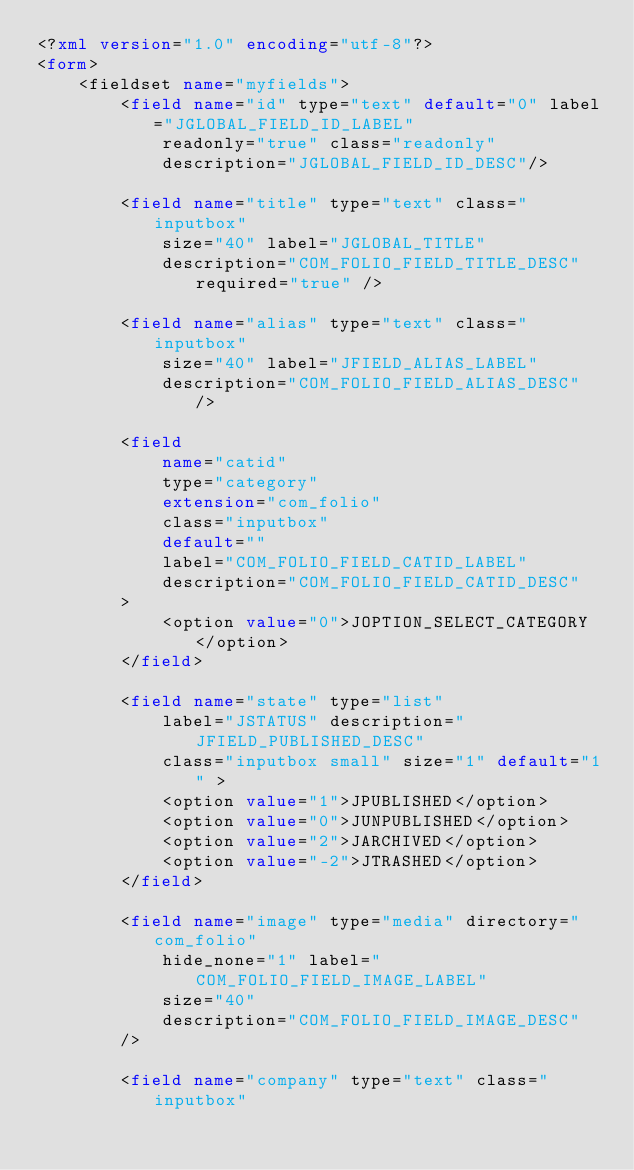Convert code to text. <code><loc_0><loc_0><loc_500><loc_500><_XML_><?xml version="1.0" encoding="utf-8"?>
<form>
	<fieldset name="myfields">
		<field name="id" type="text" default="0" label="JGLOBAL_FIELD_ID_LABEL"
			readonly="true" class="readonly"
			description="JGLOBAL_FIELD_ID_DESC"/>

		<field name="title" type="text" class="inputbox"
			size="40" label="JGLOBAL_TITLE"
			description="COM_FOLIO_FIELD_TITLE_DESC" required="true" />

		<field name="alias" type="text" class="inputbox"
			size="40" label="JFIELD_ALIAS_LABEL"
			description="COM_FOLIO_FIELD_ALIAS_DESC" />

		<field
			name="catid"
			type="category"
			extension="com_folio"
			class="inputbox"
			default=""
			label="COM_FOLIO_FIELD_CATID_LABEL"
			description="COM_FOLIO_FIELD_CATID_DESC"
		>
			<option value="0">JOPTION_SELECT_CATEGORY</option>
		</field>
		
		<field name="state" type="list"
			label="JSTATUS" description="JFIELD_PUBLISHED_DESC"
			class="inputbox small" size="1" default="1" >
			<option value="1">JPUBLISHED</option>
			<option value="0">JUNPUBLISHED</option>
			<option value="2">JARCHIVED</option>
			<option value="-2">JTRASHED</option>
		</field>

		<field name="image" type="media" directory="com_folio"
			hide_none="1" label="COM_FOLIO_FIELD_IMAGE_LABEL"
			size="40"
			description="COM_FOLIO_FIELD_IMAGE_DESC" 
		/>
		
		<field name="company" type="text" class="inputbox"</code> 